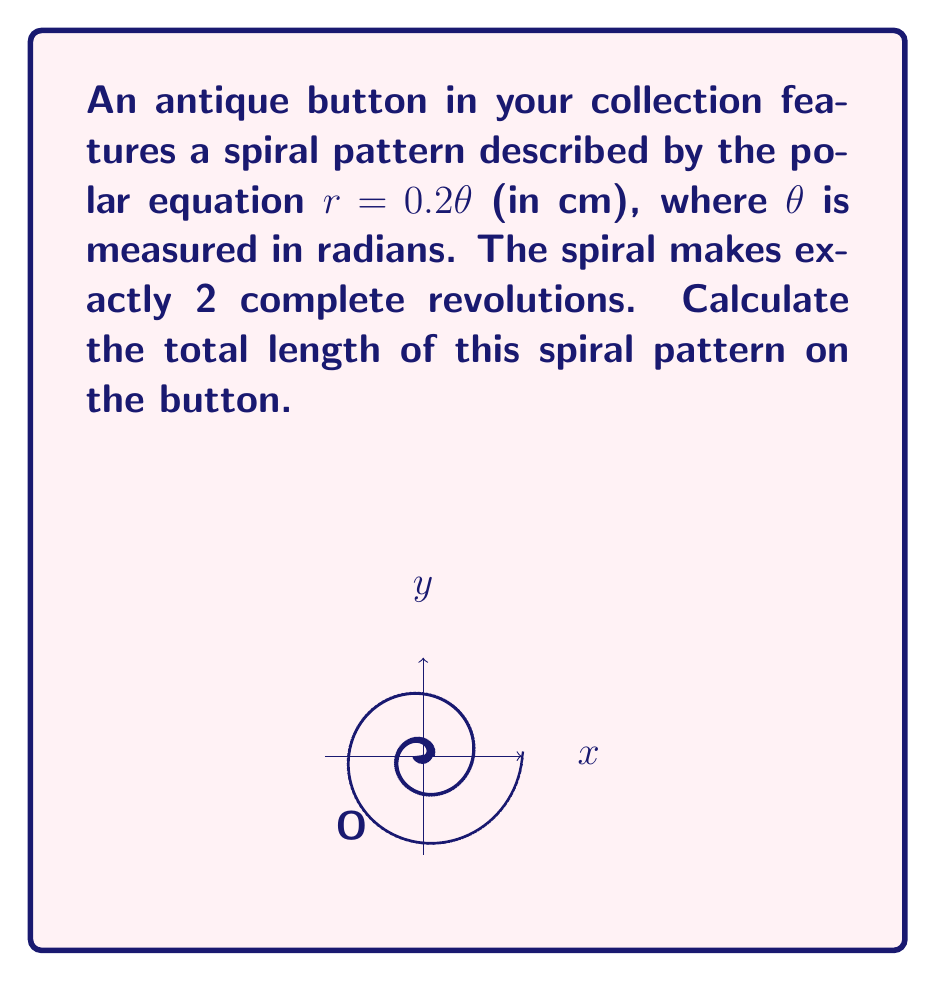Help me with this question. To find the length of the spiral, we'll use the arc length formula for polar curves:

$$L = \int_a^b \sqrt{r^2 + \left(\frac{dr}{d\theta}\right)^2} d\theta$$

1) First, we need $r$ and $\frac{dr}{d\theta}$:
   $r = 0.2\theta$
   $\frac{dr}{d\theta} = 0.2$

2) Substitute these into the formula:
   $$L = \int_0^{4\pi} \sqrt{(0.2\theta)^2 + (0.2)^2} d\theta$$

3) Simplify under the square root:
   $$L = \int_0^{4\pi} \sqrt{0.04\theta^2 + 0.04} d\theta$$
   $$L = 0.2 \int_0^{4\pi} \sqrt{\theta^2 + 1} d\theta$$

4) This integral doesn't have an elementary antiderivative. We can solve it using the substitution $\theta = \sinh u$:
   $$L = 0.2 \int_0^{\sinh^{-1}(4\pi)} \sqrt{\sinh^2 u + 1} \cosh u du$$

5) Simplify using the identity $\sinh^2 u + 1 = \cosh^2 u$:
   $$L = 0.2 \int_0^{\sinh^{-1}(4\pi)} \cosh^2 u du$$

6) Use the identity $\cosh^2 u = \frac{1}{2}(\cosh 2u + 1)$:
   $$L = 0.1 \int_0^{\sinh^{-1}(4\pi)} (\cosh 2u + 1) du$$

7) Integrate:
   $$L = 0.1 \left[\frac{1}{2}\sinh 2u + u\right]_0^{\sinh^{-1}(4\pi)}$$

8) Evaluate the definite integral:
   $$L = 0.1 \left(\frac{1}{2}\sinh(2\sinh^{-1}(4\pi)) + \sinh^{-1}(4\pi)\right)$$

9) Simplify using $\sinh(2\sinh^{-1}(x)) = 2x\sqrt{1+x^2}$:
   $$L = 0.1 \left(4\pi\sqrt{1+(4\pi)^2} + \sinh^{-1}(4\pi)\right)$$

10) Calculate the final value (rounded to 3 decimal places):
    $$L \approx 5.026 \text{ cm}$$
Answer: $5.026 \text{ cm}$ 